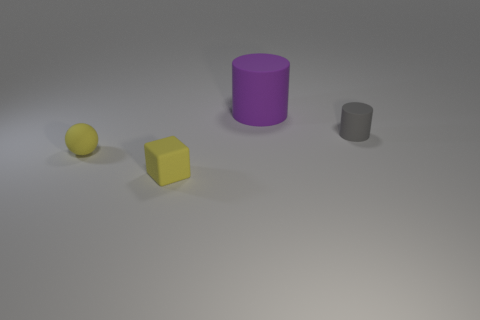Are there any small yellow matte blocks on the right side of the small rubber object that is on the right side of the cylinder on the left side of the gray cylinder?
Your answer should be compact. No. There is a gray thing; are there any tiny cubes behind it?
Provide a short and direct response. No. Are there any things that have the same color as the small rubber block?
Ensure brevity in your answer.  Yes. What number of small things are either brown rubber balls or blocks?
Your answer should be compact. 1. Is the material of the small object right of the large purple cylinder the same as the small ball?
Make the answer very short. Yes. There is a matte object that is behind the tiny object behind the sphere in front of the purple cylinder; what shape is it?
Your answer should be very brief. Cylinder. What number of purple things are big matte cylinders or rubber cubes?
Your answer should be very brief. 1. Are there the same number of small yellow matte objects that are on the left side of the big object and big purple cylinders that are to the left of the rubber sphere?
Offer a very short reply. No. There is a matte thing behind the tiny rubber cylinder; does it have the same shape as the thing that is right of the purple matte thing?
Provide a succinct answer. Yes. Is there any other thing that has the same shape as the gray object?
Keep it short and to the point. Yes. 